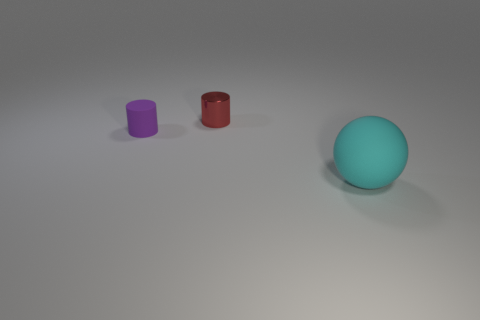Are the thing behind the small purple thing and the large cyan object made of the same material?
Give a very brief answer. No. Are there the same number of large spheres that are behind the purple rubber object and purple matte cylinders on the left side of the red metal cylinder?
Offer a very short reply. No. There is a cyan thing that is in front of the red object; what size is it?
Provide a succinct answer. Large. Is there a cylinder that has the same material as the cyan sphere?
Offer a terse response. Yes. Is the number of tiny purple things that are on the left side of the tiny purple thing the same as the number of yellow metal cylinders?
Give a very brief answer. Yes. Is there a small shiny cylinder of the same color as the large sphere?
Offer a very short reply. No. Do the red cylinder and the purple matte thing have the same size?
Offer a very short reply. Yes. There is a object in front of the matte thing on the left side of the large rubber thing; what is its size?
Give a very brief answer. Large. There is a thing that is both in front of the red shiny cylinder and behind the cyan sphere; how big is it?
Your answer should be compact. Small. How many other cylinders have the same size as the purple cylinder?
Make the answer very short. 1. 